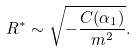Convert formula to latex. <formula><loc_0><loc_0><loc_500><loc_500>R ^ { \ast } \sim \sqrt { - \frac { C ( \alpha _ { 1 } ) } { m ^ { 2 } } } .</formula> 